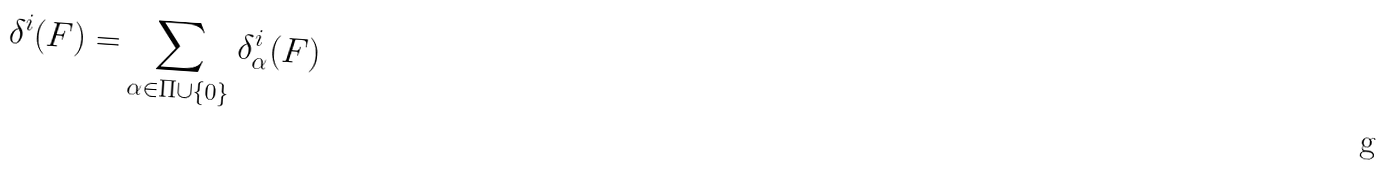<formula> <loc_0><loc_0><loc_500><loc_500>\delta ^ { i } ( F ) = \sum _ { \alpha \in \Pi \cup \{ 0 \} } \delta _ { \alpha } ^ { i } ( F )</formula> 